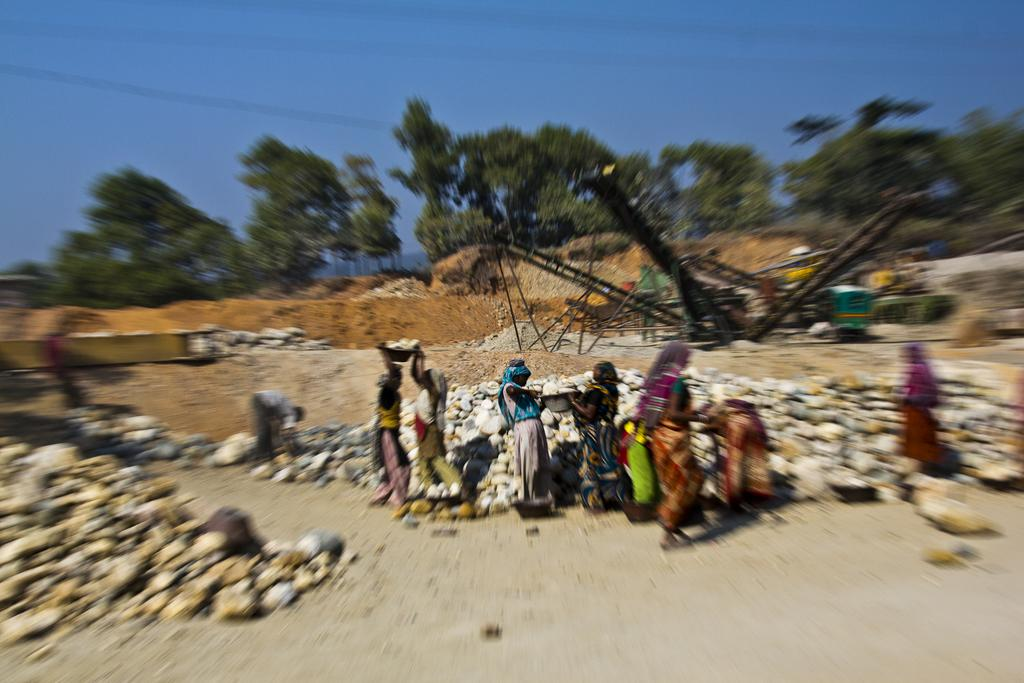How many people are in the image? There is a group of people in the image, but the exact number cannot be determined from the provided facts. What is on the ground in the image? There are stones on the ground in the image. What type of vegetation is present in the image? There are trees in the image. What can be seen in the background of the image? The sky is visible in the background of the image. What type of canvas is being used by the people in the image? There is: There is no canvas present in the image; it features a group of people, stones on the ground, trees, and a visible sky. 